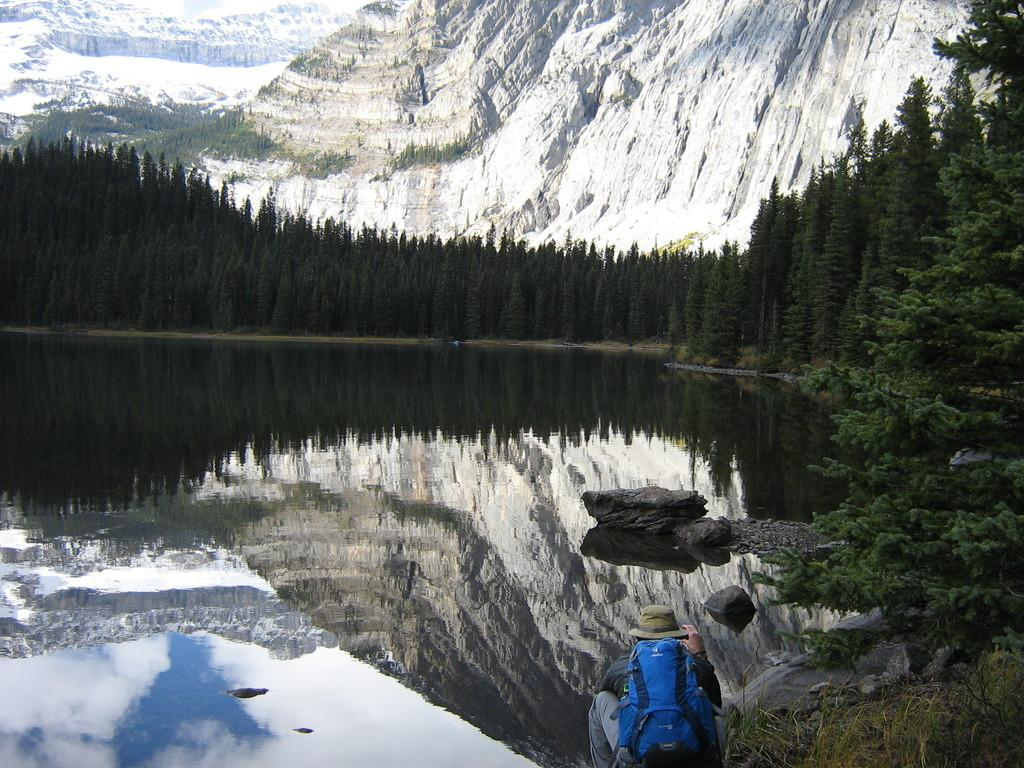What is the main subject in the foreground of the image? There is a person in the foreground of the image. What is the person wearing? The person is wearing a bag and a hat. What position is the person in? The person is squatting. What can be seen in the background of the image? There are trees, water, rocks, and mountains visible in the background of the image. What type of fang can be seen in the person's mouth in the image? There is no fang visible in the person's mouth in the image. How many dolls are sitting on the rocks in the background of the image? There are no dolls present in the image; only trees, water, rocks, and mountains can be seen in the background. 